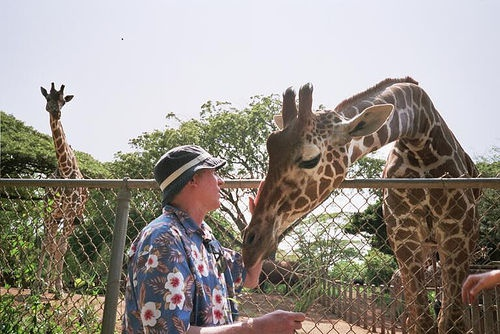Describe the objects in this image and their specific colors. I can see giraffe in lavender, gray, black, and maroon tones, people in lavender, gray, brown, black, and darkgray tones, and giraffe in lavender, gray, black, and maroon tones in this image. 